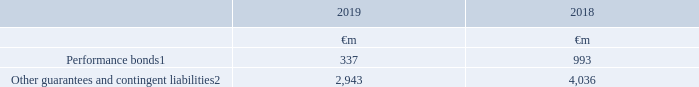28. Contingent liabilities and legal proceedings
Contingent liabilities are potential future cash outflows, where the likelihood of payment is considered more than remote, but is not considered probable or cannot be measured reliably.
Notes: 1 Performance bonds require the Group to make payments to third parties in the event that the Group does not perform what is expected of it under the terms of any related contracts or commercial arrangements
2 Other guarantees principally comprise Vodafone Group Plc’s guarantee of the Group’s 50% share of an AUD1.7 billion loan facility and a US$3.5 billion loan facility of its joint venture, Vodafone Hutchison Australia Pty Limited. The Group’s share of these loan balances is included in the net investment in joint venture (see note 12 “Investments in associates and joint arrangements”).
What does contingent liabilities consist of? Performance bonds, other guarantees and contingent liabilities. What are contingent liabilities? Potential future cash outflows, where the likelihood of payment is considered more than remote, but is not considered probable or cannot be measured reliably. How much are the 2019 performance bonds?
Answer scale should be: million. 337. What is the 2019 average performance bonds?
Answer scale should be: million. (337+993)/2
Answer: 665. What is the 2019 average other guarantees and contingent liabilities?
Answer scale should be: million. (2,943+4,036)/2
Answer: 3489.5. What is the difference between 2019 average performance bonds and 2019 average other guarantees and contingent liabilities?
Answer scale should be: million. [(2,943+4,036)/2] - [(337+993)/2]
Answer: 2824.5. 